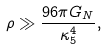<formula> <loc_0><loc_0><loc_500><loc_500>\rho \gg \frac { 9 6 \pi G _ { N } } { \kappa _ { 5 } ^ { 4 } } ,</formula> 